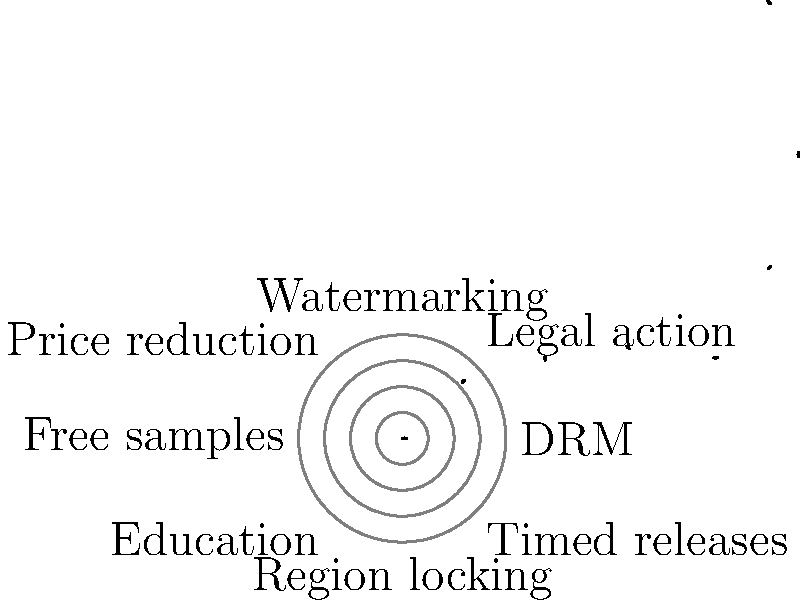Based on the polar coordinate graph showing the effectiveness of various anti-piracy measures, which method appears to be the most effective in reducing illegal downloads of your latest novel? To determine the most effective anti-piracy measure, we need to analyze the polar coordinate graph:

1. The graph shows 8 different anti-piracy measures, each represented by a vector.
2. The length of each vector indicates the effectiveness of the measure.
3. A longer vector means greater effectiveness in reducing illegal downloads.
4. The measures and their relative effectiveness are:
   a. DRM (0°): Longest vector
   b. Legal action (45°): Second longest vector
   c. Watermarking (90°): Medium length vector
   d. Price reduction (135°): Short vector
   e. Free samples (180°): Shortest vector
   f. Education (225°): Short-medium vector
   g. Region locking (270°): Medium-long vector
   h. Timed releases (315°): Long vector

5. Comparing the lengths of all vectors, we can see that the longest vector corresponds to DRM (Digital Rights Management) at 0°.

Therefore, according to this graph, DRM appears to be the most effective method in reducing illegal downloads of your latest novel.
Answer: DRM (Digital Rights Management) 